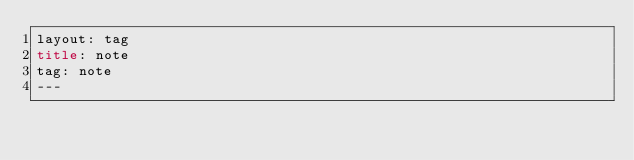Convert code to text. <code><loc_0><loc_0><loc_500><loc_500><_HTML_>layout: tag
title: note
tag: note
---
</code> 